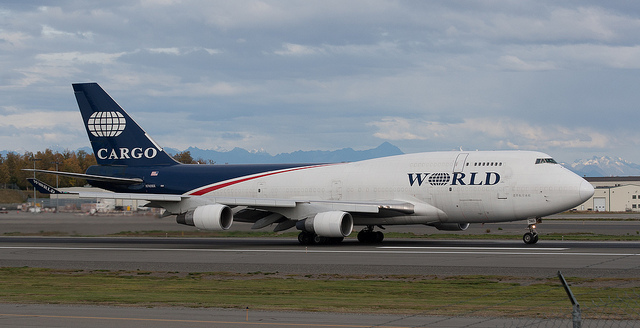Please transcribe the text in this image. CARGO WORLD 